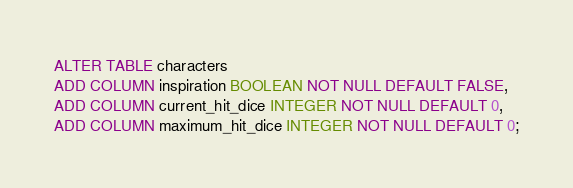<code> <loc_0><loc_0><loc_500><loc_500><_SQL_>ALTER TABLE characters
ADD COLUMN inspiration BOOLEAN NOT NULL DEFAULT FALSE,
ADD COLUMN current_hit_dice INTEGER NOT NULL DEFAULT 0,
ADD COLUMN maximum_hit_dice INTEGER NOT NULL DEFAULT 0;</code> 